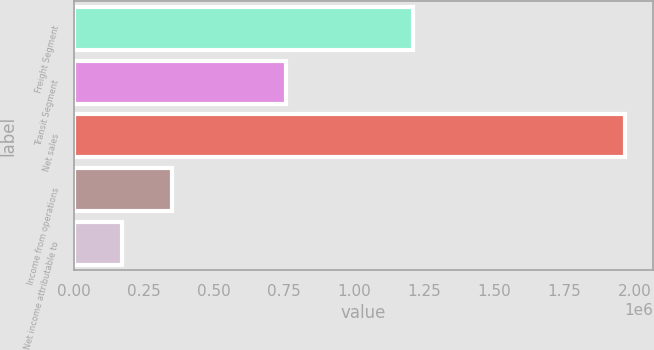Convert chart. <chart><loc_0><loc_0><loc_500><loc_500><bar_chart><fcel>Freight Segment<fcel>Transit Segment<fcel>Net sales<fcel>Income from operations<fcel>Net income attributable to<nl><fcel>1.21006e+06<fcel>757578<fcel>1.96764e+06<fcel>349898<fcel>170149<nl></chart> 